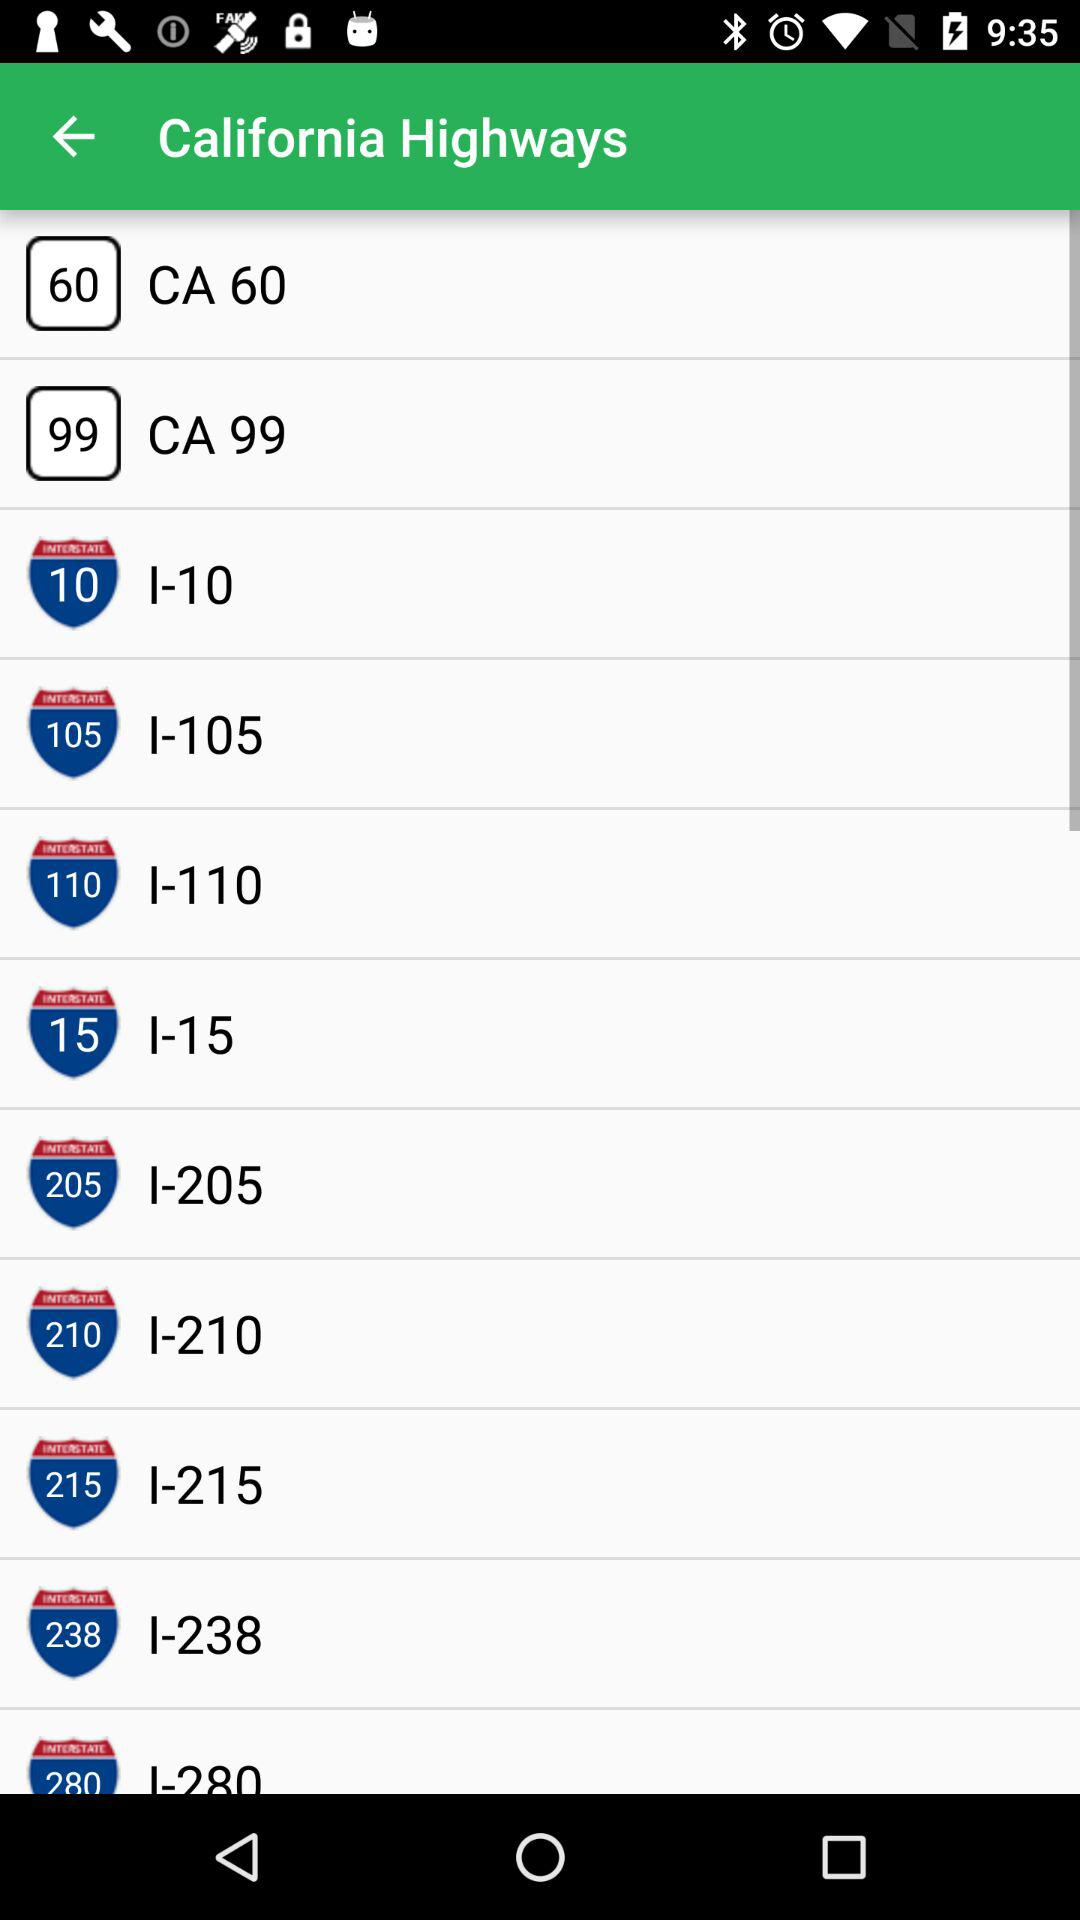Which highway is shown on 99? The highway which is shown on 99 is "CA 99". 